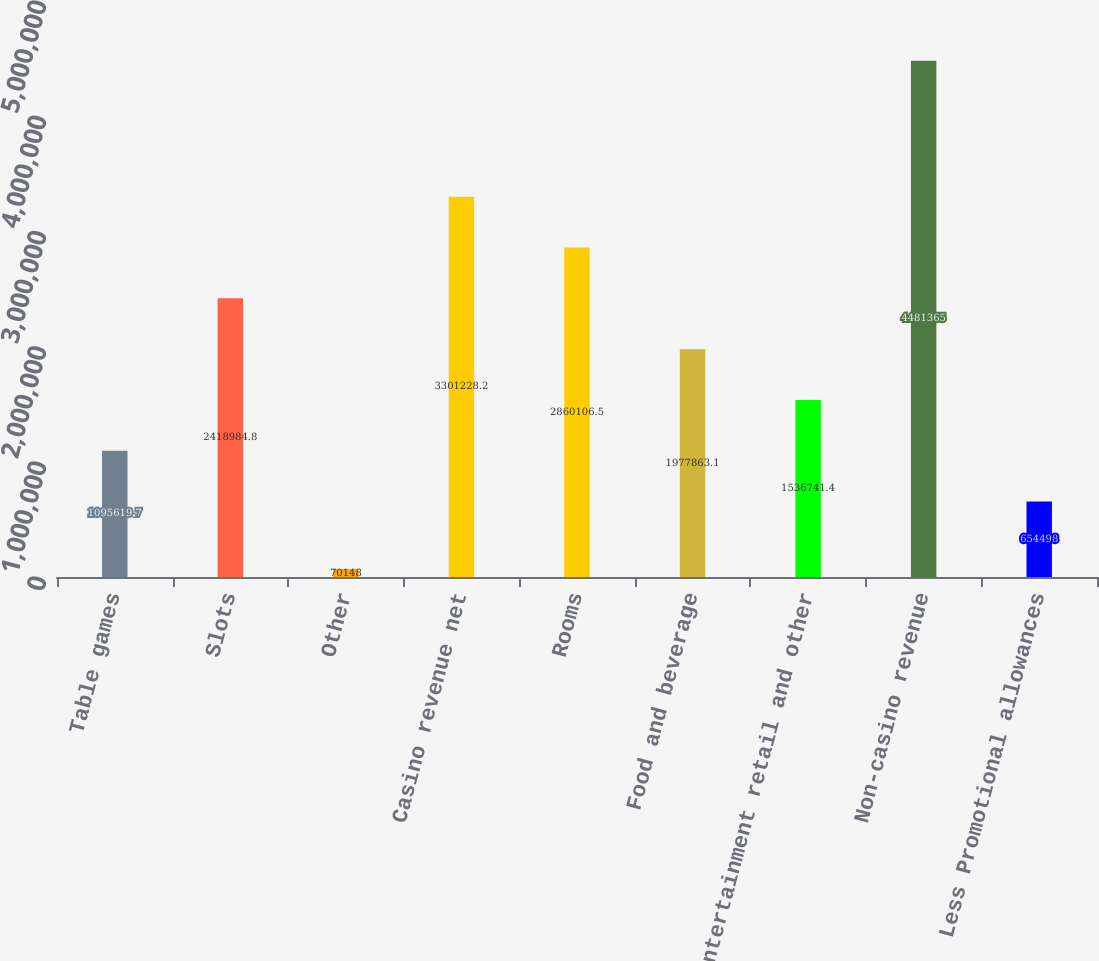Convert chart. <chart><loc_0><loc_0><loc_500><loc_500><bar_chart><fcel>Table games<fcel>Slots<fcel>Other<fcel>Casino revenue net<fcel>Rooms<fcel>Food and beverage<fcel>Entertainment retail and other<fcel>Non-casino revenue<fcel>Less Promotional allowances<nl><fcel>1.09562e+06<fcel>2.41898e+06<fcel>70148<fcel>3.30123e+06<fcel>2.86011e+06<fcel>1.97786e+06<fcel>1.53674e+06<fcel>4.48136e+06<fcel>654498<nl></chart> 